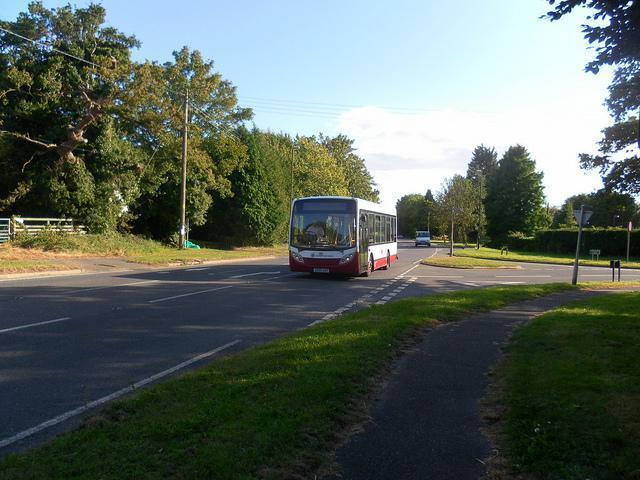How many lanes of traffic are traveling in the same direction on the road to the right?
Give a very brief answer. 1. 